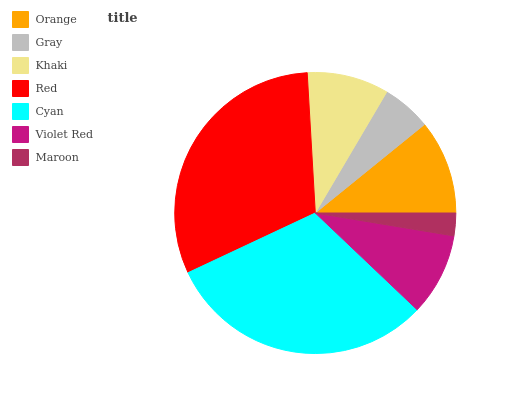Is Maroon the minimum?
Answer yes or no. Yes. Is Red the maximum?
Answer yes or no. Yes. Is Gray the minimum?
Answer yes or no. No. Is Gray the maximum?
Answer yes or no. No. Is Orange greater than Gray?
Answer yes or no. Yes. Is Gray less than Orange?
Answer yes or no. Yes. Is Gray greater than Orange?
Answer yes or no. No. Is Orange less than Gray?
Answer yes or no. No. Is Violet Red the high median?
Answer yes or no. Yes. Is Violet Red the low median?
Answer yes or no. Yes. Is Maroon the high median?
Answer yes or no. No. Is Gray the low median?
Answer yes or no. No. 